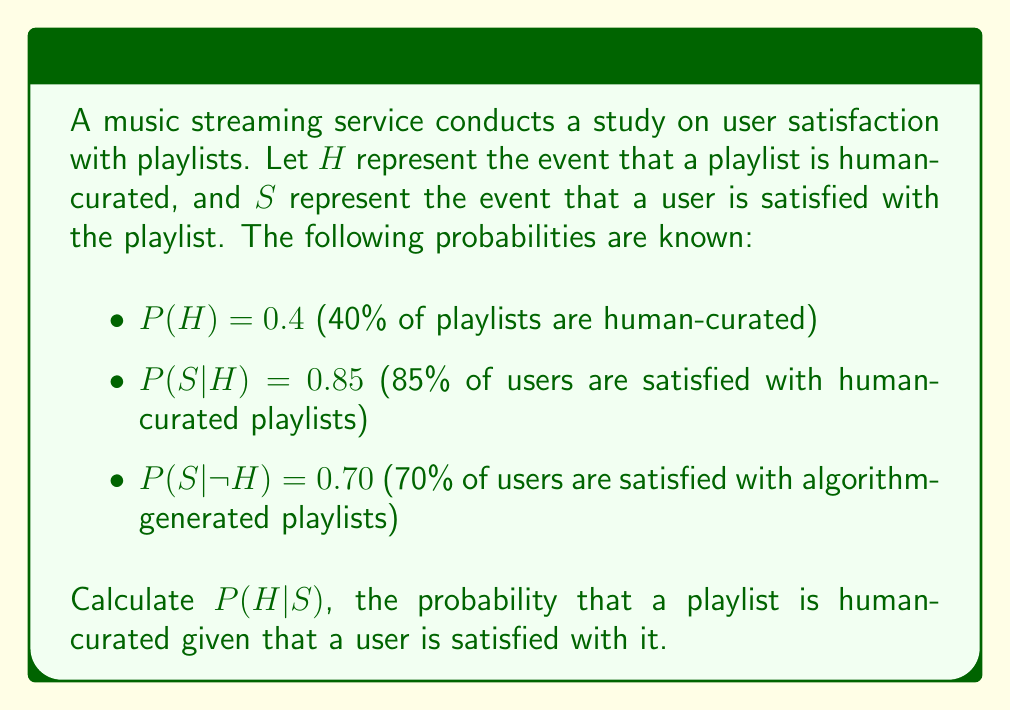Could you help me with this problem? To solve this problem, we'll use Bayes' Theorem, which is given by:

$$P(H|S) = \frac{P(S|H) \cdot P(H)}{P(S)}$$

We know $P(S|H)$ and $P(H)$, but we need to calculate $P(S)$ using the law of total probability:

$$P(S) = P(S|H) \cdot P(H) + P(S|\neg H) \cdot P(\neg H)$$

Step 1: Calculate $P(\neg H)$
$P(\neg H) = 1 - P(H) = 1 - 0.4 = 0.6$

Step 2: Calculate $P(S)$
$P(S) = 0.85 \cdot 0.4 + 0.70 \cdot 0.6$
$P(S) = 0.34 + 0.42 = 0.76$

Step 3: Apply Bayes' Theorem
$$P(H|S) = \frac{0.85 \cdot 0.4}{0.76} = \frac{0.34}{0.76} = \frac{17}{38} \approx 0.4474$$

Therefore, the probability that a playlist is human-curated given that a user is satisfied with it is approximately 0.4474 or 44.74%.
Answer: $P(H|S) = \frac{17}{38} \approx 0.4474$ or 44.74% 